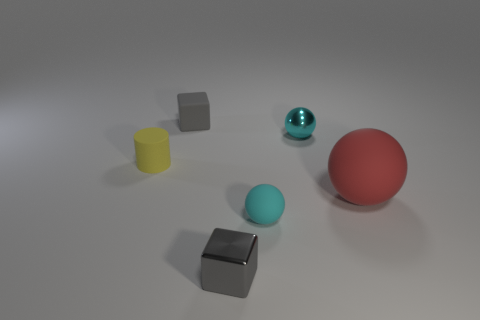Subtract all small shiny balls. How many balls are left? 2 Add 2 small gray blocks. How many objects exist? 8 Subtract all cubes. How many objects are left? 4 Add 3 gray matte things. How many gray matte things are left? 4 Add 6 big cyan cubes. How many big cyan cubes exist? 6 Subtract 0 blue cylinders. How many objects are left? 6 Subtract all small cyan matte spheres. Subtract all small brown matte blocks. How many objects are left? 5 